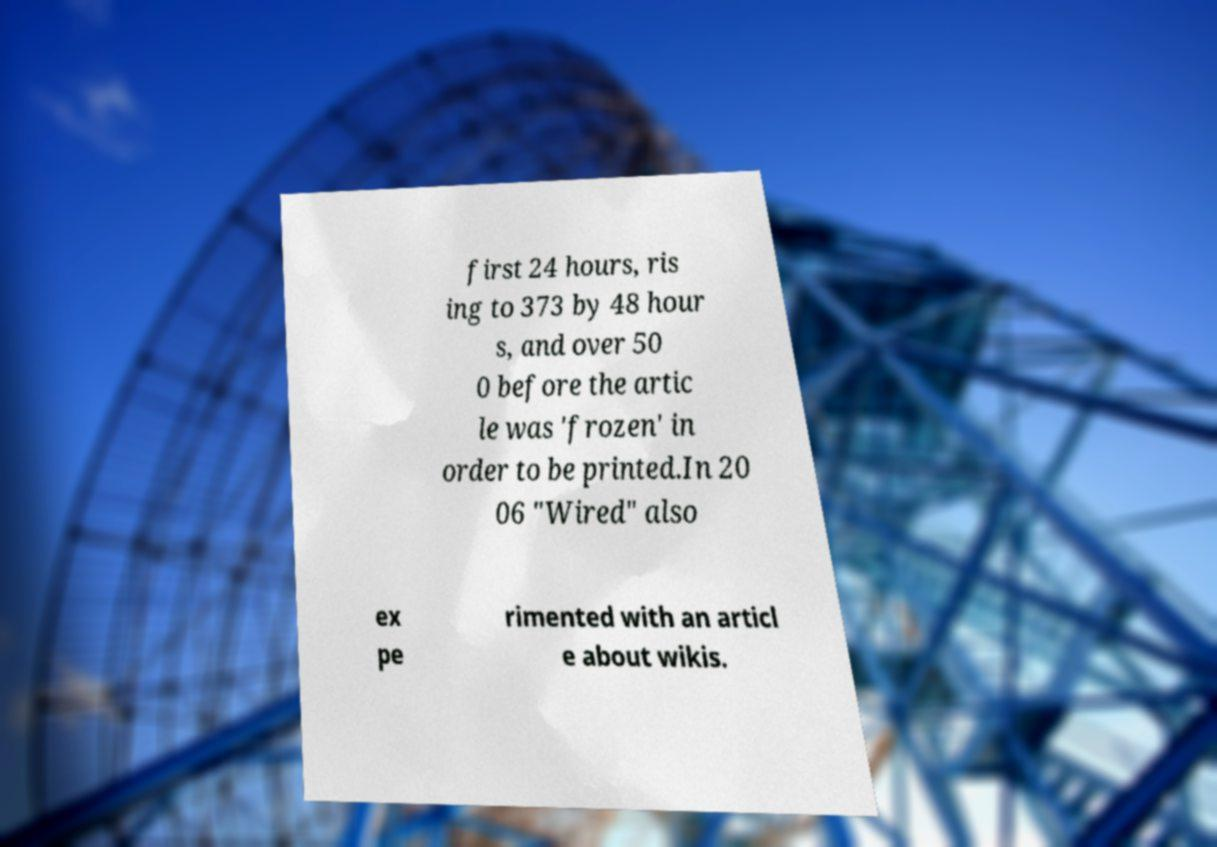Can you read and provide the text displayed in the image?This photo seems to have some interesting text. Can you extract and type it out for me? first 24 hours, ris ing to 373 by 48 hour s, and over 50 0 before the artic le was 'frozen' in order to be printed.In 20 06 "Wired" also ex pe rimented with an articl e about wikis. 